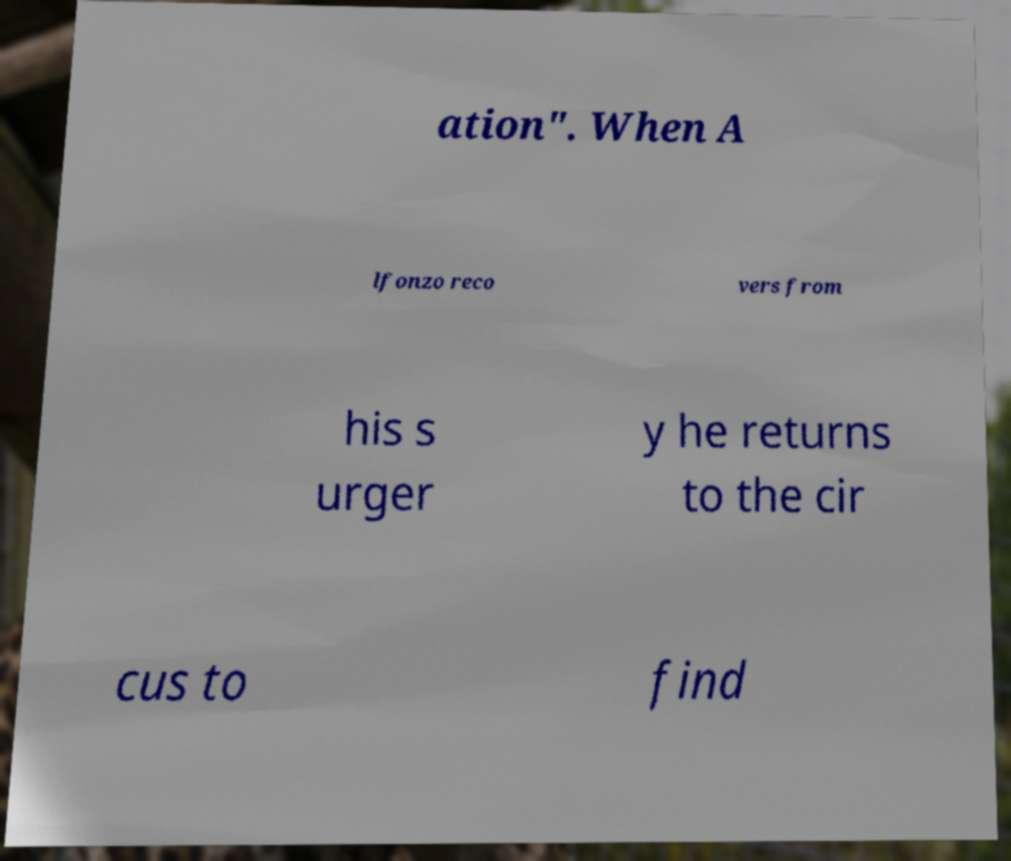I need the written content from this picture converted into text. Can you do that? ation". When A lfonzo reco vers from his s urger y he returns to the cir cus to find 